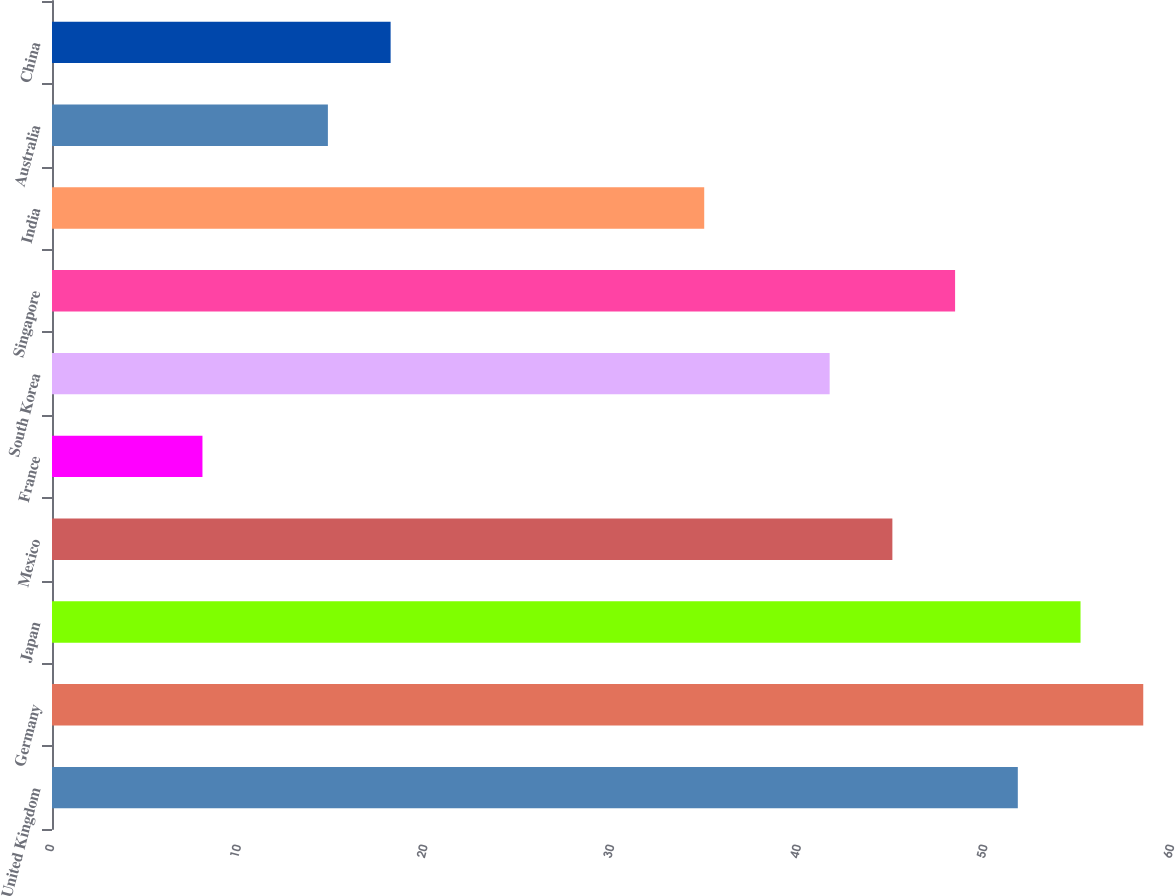<chart> <loc_0><loc_0><loc_500><loc_500><bar_chart><fcel>United Kingdom<fcel>Germany<fcel>Japan<fcel>Mexico<fcel>France<fcel>South Korea<fcel>Singapore<fcel>India<fcel>Australia<fcel>China<nl><fcel>51.74<fcel>58.46<fcel>55.1<fcel>45.02<fcel>8.06<fcel>41.66<fcel>48.38<fcel>34.94<fcel>14.78<fcel>18.14<nl></chart> 